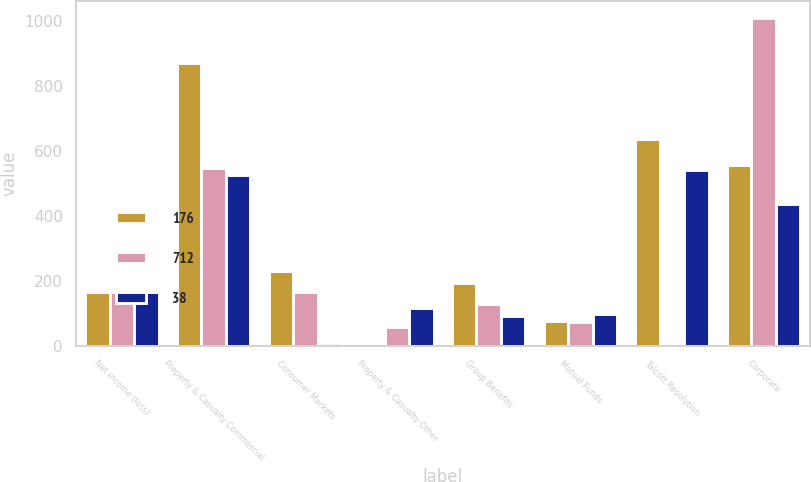Convert chart to OTSL. <chart><loc_0><loc_0><loc_500><loc_500><stacked_bar_chart><ecel><fcel>Net income (loss)<fcel>Property & Casualty Commercial<fcel>Consumer Markets<fcel>Property & Casualty Other<fcel>Group Benefits<fcel>Mutual Funds<fcel>Talcott Resolution<fcel>Corporate<nl><fcel>176<fcel>166<fcel>870<fcel>229<fcel>2<fcel>192<fcel>76<fcel>634<fcel>555<nl><fcel>712<fcel>166<fcel>547<fcel>166<fcel>57<fcel>129<fcel>71<fcel>1<fcel>1009<nl><fcel>38<fcel>166<fcel>526<fcel>7<fcel>117<fcel>92<fcel>98<fcel>540<fcel>434<nl></chart> 